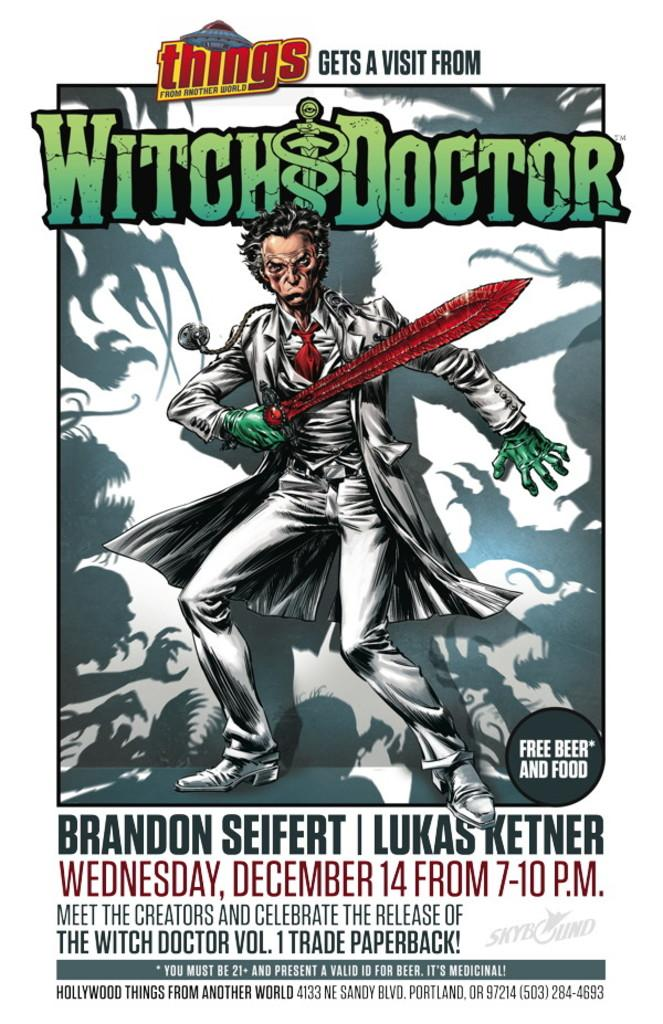<image>
Offer a succinct explanation of the picture presented. A poster advertising a paperback for the Witch Doctor 